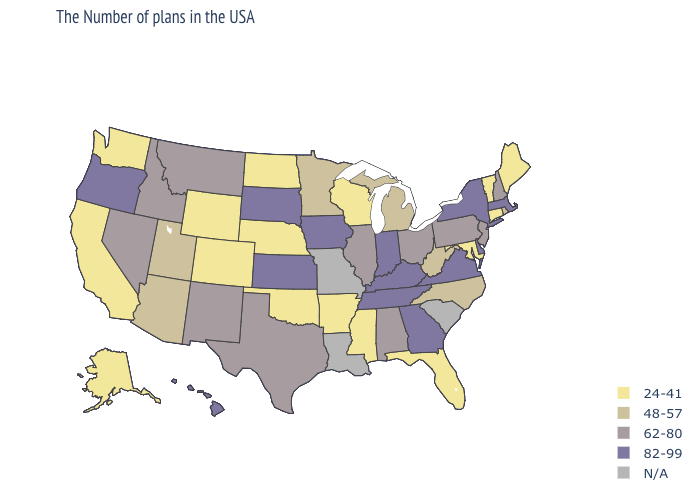Name the states that have a value in the range N/A?
Keep it brief. South Carolina, Louisiana, Missouri. What is the highest value in states that border Tennessee?
Concise answer only. 82-99. What is the value of Nebraska?
Be succinct. 24-41. Name the states that have a value in the range 62-80?
Keep it brief. New Hampshire, New Jersey, Pennsylvania, Ohio, Alabama, Illinois, Texas, New Mexico, Montana, Idaho, Nevada. Is the legend a continuous bar?
Write a very short answer. No. What is the value of Iowa?
Answer briefly. 82-99. Name the states that have a value in the range 82-99?
Concise answer only. Massachusetts, New York, Delaware, Virginia, Georgia, Kentucky, Indiana, Tennessee, Iowa, Kansas, South Dakota, Oregon, Hawaii. Does Colorado have the lowest value in the USA?
Keep it brief. Yes. What is the highest value in states that border Rhode Island?
Concise answer only. 82-99. Which states have the lowest value in the USA?
Give a very brief answer. Maine, Vermont, Connecticut, Maryland, Florida, Wisconsin, Mississippi, Arkansas, Nebraska, Oklahoma, North Dakota, Wyoming, Colorado, California, Washington, Alaska. Name the states that have a value in the range 24-41?
Concise answer only. Maine, Vermont, Connecticut, Maryland, Florida, Wisconsin, Mississippi, Arkansas, Nebraska, Oklahoma, North Dakota, Wyoming, Colorado, California, Washington, Alaska. What is the value of Kansas?
Be succinct. 82-99. What is the value of New York?
Quick response, please. 82-99. What is the value of Michigan?
Be succinct. 48-57. How many symbols are there in the legend?
Answer briefly. 5. 